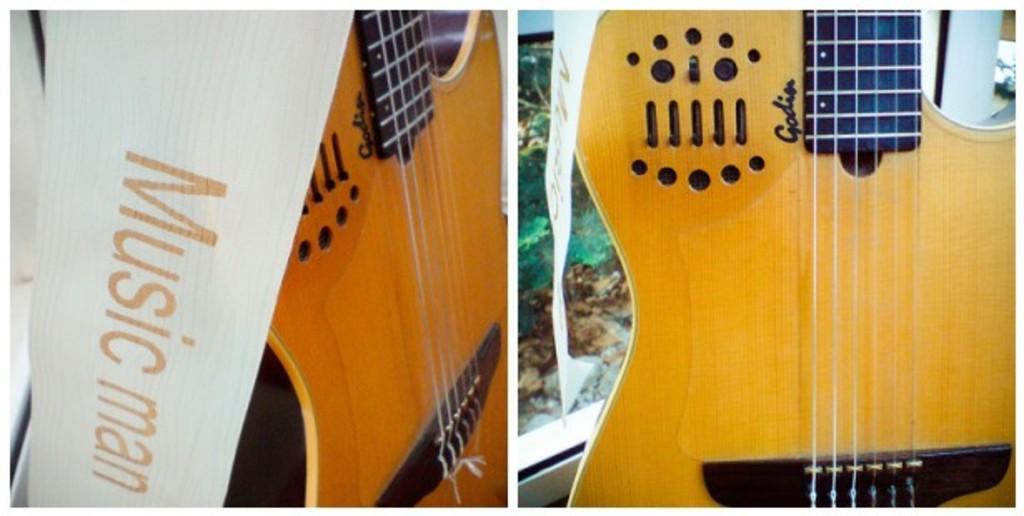Describe this image in one or two sentences. In this image I can see two guitars and with the name music man. 